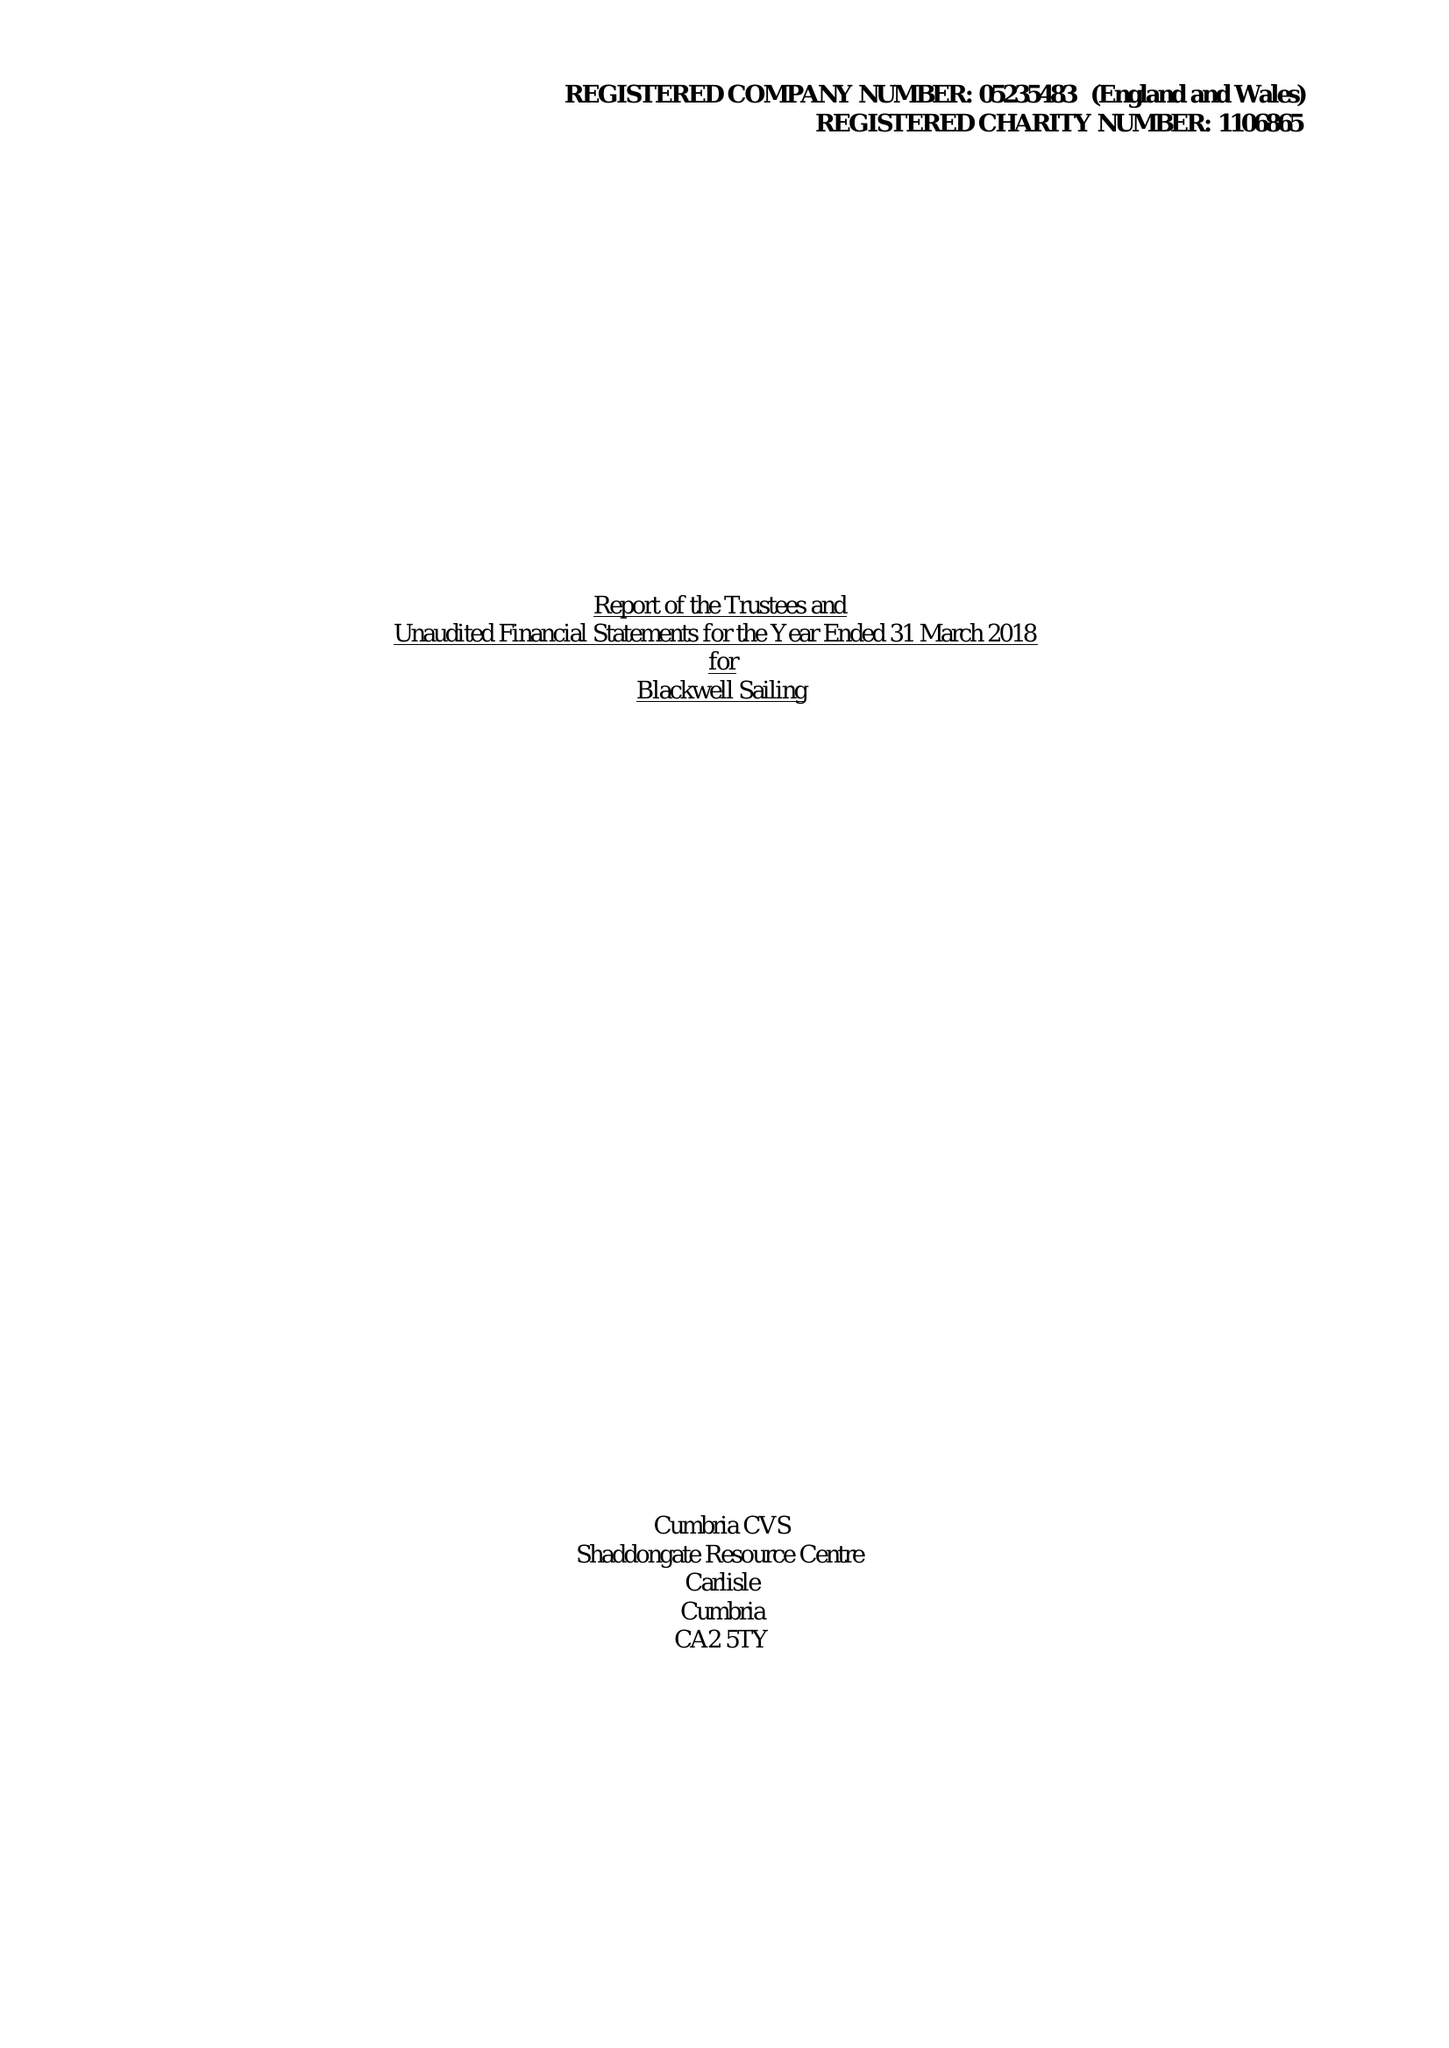What is the value for the charity_number?
Answer the question using a single word or phrase. 1106865 